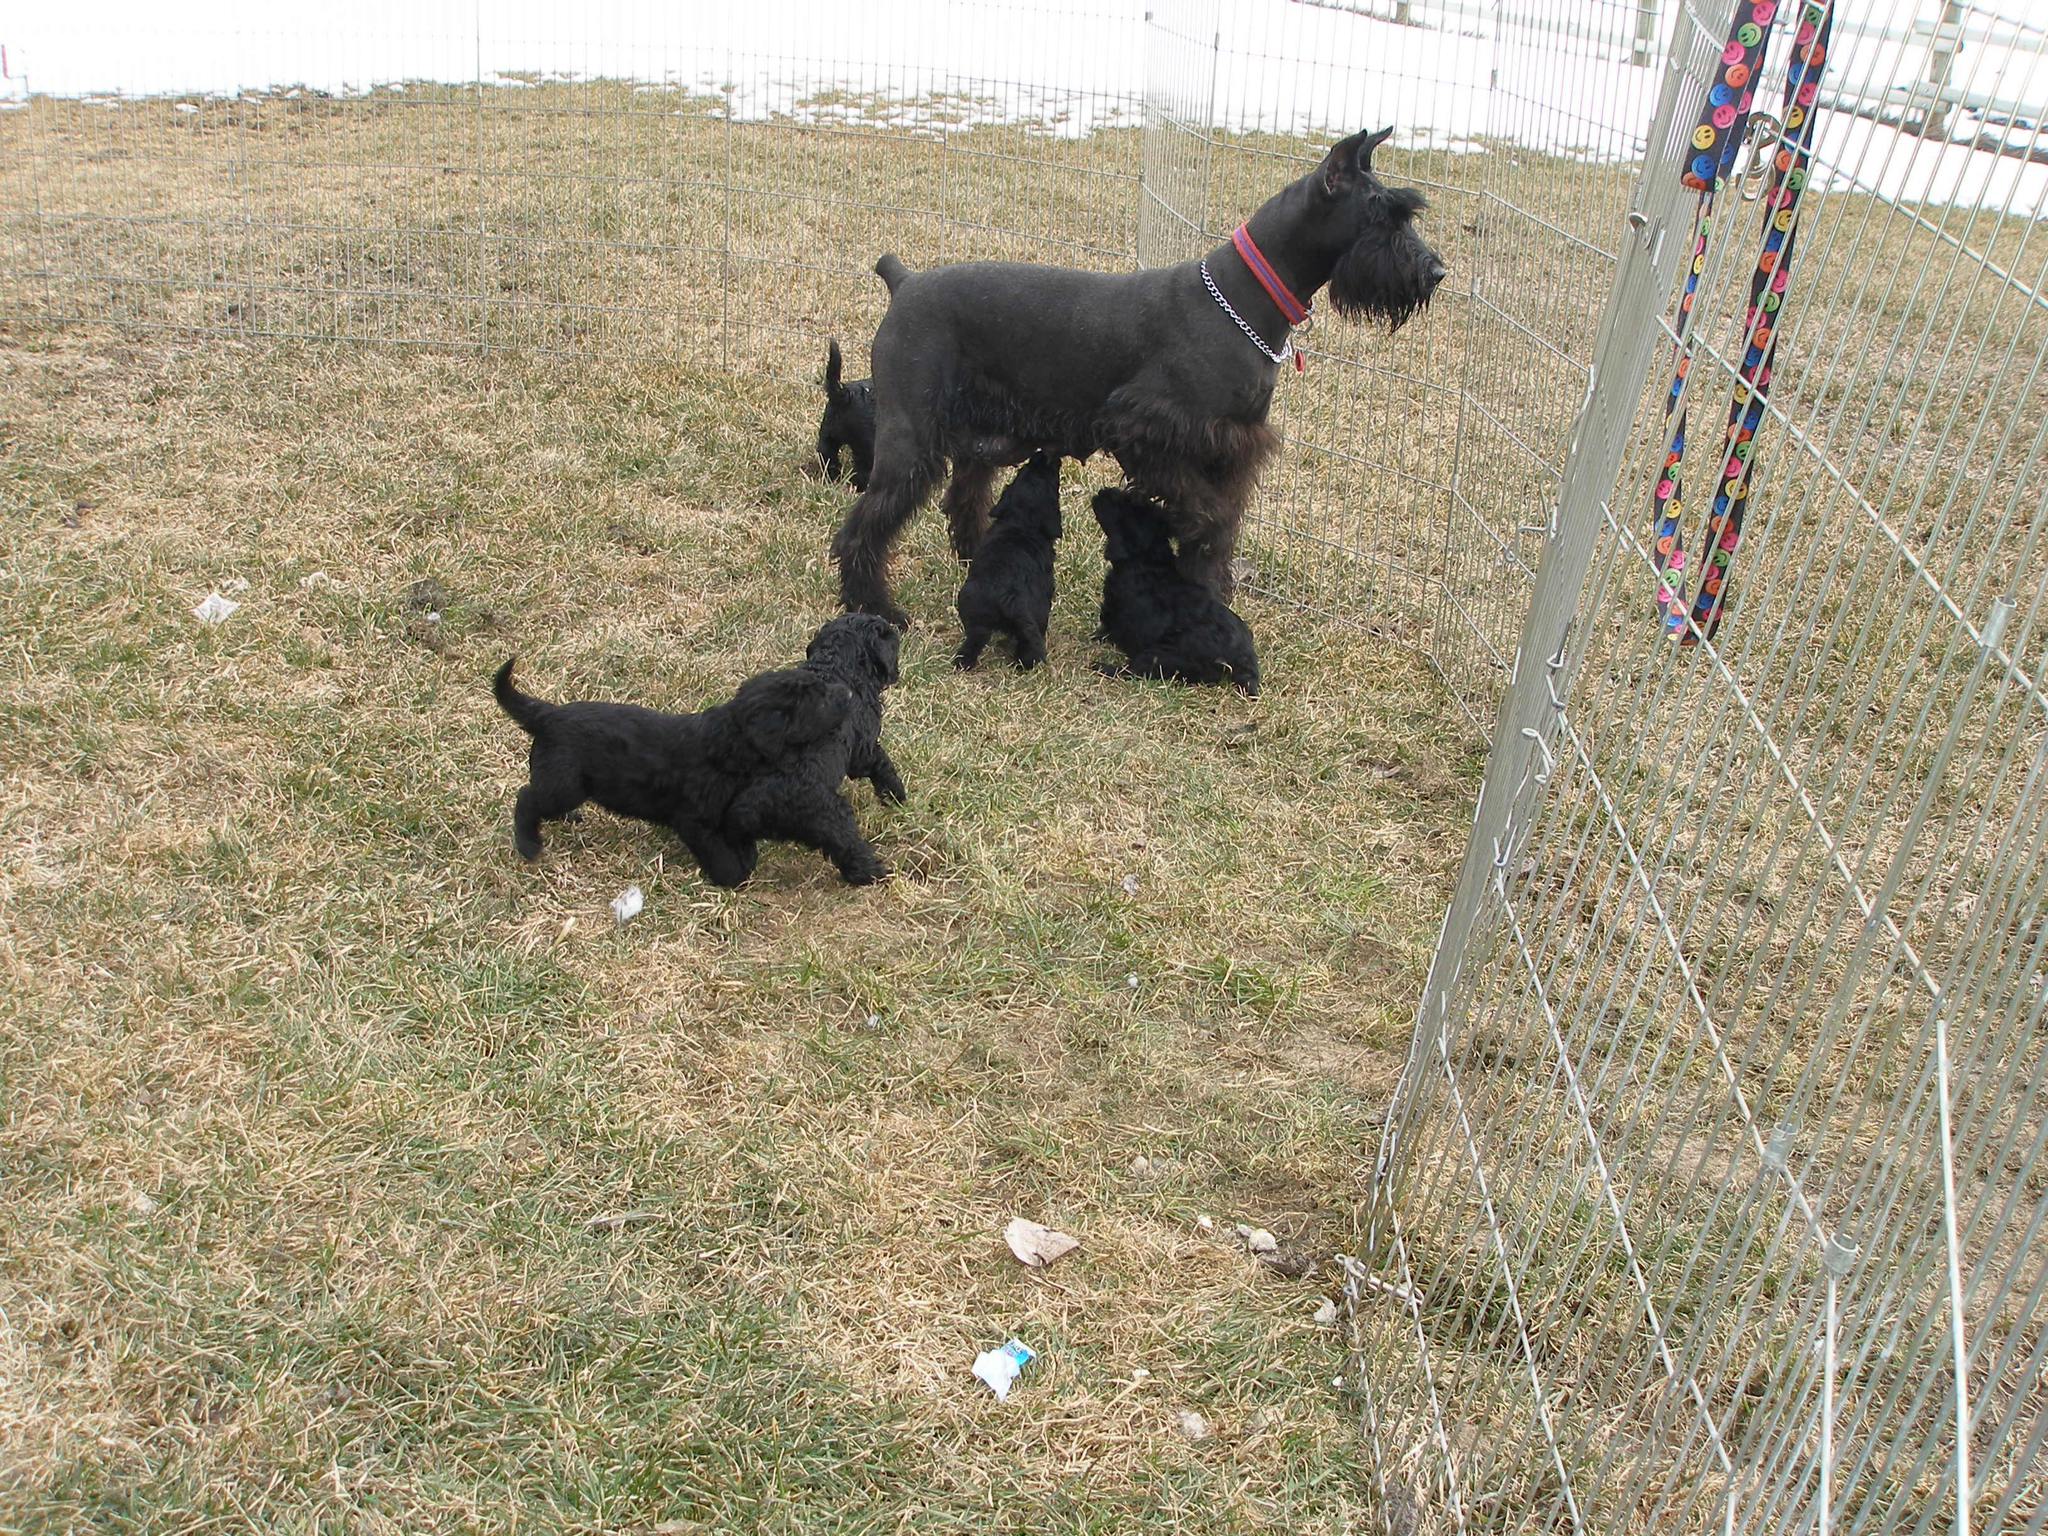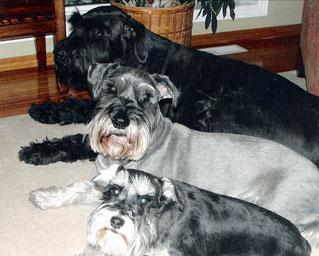The first image is the image on the left, the second image is the image on the right. Given the left and right images, does the statement "Each image contains exactly one schnauzer, and one image shows a schnauzer in some type of bed." hold true? Answer yes or no. No. The first image is the image on the left, the second image is the image on the right. Examine the images to the left and right. Is the description "there is a dog laying in bed" accurate? Answer yes or no. No. 